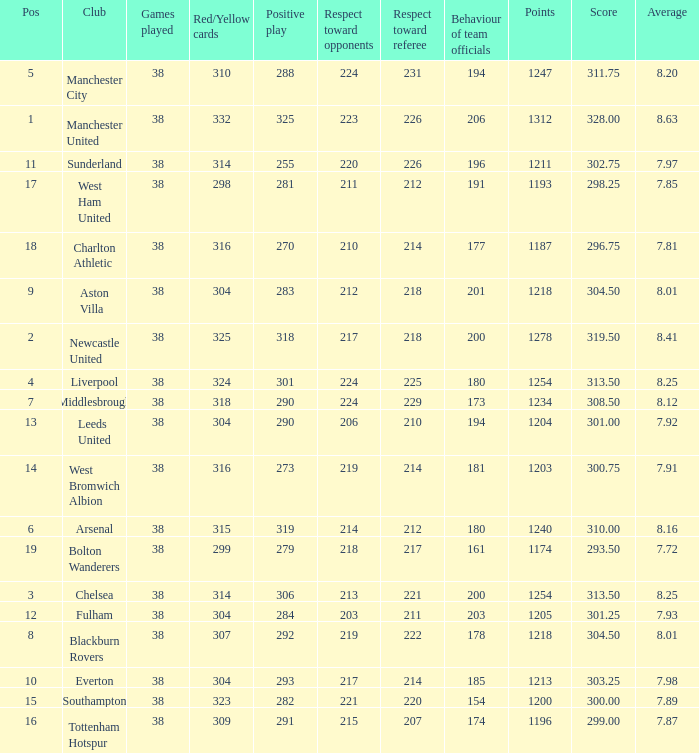Help me parse the entirety of this table. {'header': ['Pos', 'Club', 'Games played', 'Red/Yellow cards', 'Positive play', 'Respect toward opponents', 'Respect toward referee', 'Behaviour of team officials', 'Points', 'Score', 'Average'], 'rows': [['5', 'Manchester City', '38', '310', '288', '224', '231', '194', '1247', '311.75', '8.20'], ['1', 'Manchester United', '38', '332', '325', '223', '226', '206', '1312', '328.00', '8.63'], ['11', 'Sunderland', '38', '314', '255', '220', '226', '196', '1211', '302.75', '7.97'], ['17', 'West Ham United', '38', '298', '281', '211', '212', '191', '1193', '298.25', '7.85'], ['18', 'Charlton Athletic', '38', '316', '270', '210', '214', '177', '1187', '296.75', '7.81'], ['9', 'Aston Villa', '38', '304', '283', '212', '218', '201', '1218', '304.50', '8.01'], ['2', 'Newcastle United', '38', '325', '318', '217', '218', '200', '1278', '319.50', '8.41'], ['4', 'Liverpool', '38', '324', '301', '224', '225', '180', '1254', '313.50', '8.25'], ['7', 'Middlesbrough', '38', '318', '290', '224', '229', '173', '1234', '308.50', '8.12'], ['13', 'Leeds United', '38', '304', '290', '206', '210', '194', '1204', '301.00', '7.92'], ['14', 'West Bromwich Albion', '38', '316', '273', '219', '214', '181', '1203', '300.75', '7.91'], ['6', 'Arsenal', '38', '315', '319', '214', '212', '180', '1240', '310.00', '8.16'], ['19', 'Bolton Wanderers', '38', '299', '279', '218', '217', '161', '1174', '293.50', '7.72'], ['3', 'Chelsea', '38', '314', '306', '213', '221', '200', '1254', '313.50', '8.25'], ['12', 'Fulham', '38', '304', '284', '203', '211', '203', '1205', '301.25', '7.93'], ['8', 'Blackburn Rovers', '38', '307', '292', '219', '222', '178', '1218', '304.50', '8.01'], ['10', 'Everton', '38', '304', '293', '217', '214', '185', '1213', '303.25', '7.98'], ['15', 'Southampton', '38', '323', '282', '221', '220', '154', '1200', '300.00', '7.89'], ['16', 'Tottenham Hotspur', '38', '309', '291', '215', '207', '174', '1196', '299.00', '7.87']]} Name the most pos for west bromwich albion club 14.0. 